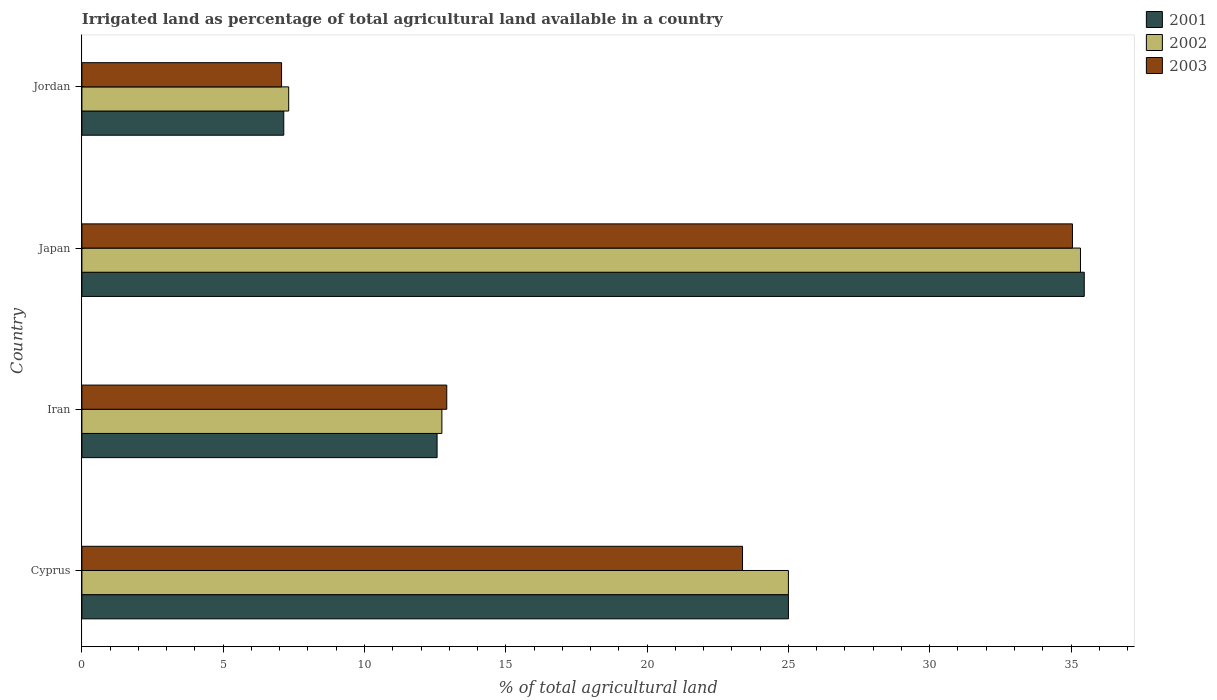How many groups of bars are there?
Your response must be concise. 4. Are the number of bars on each tick of the Y-axis equal?
Offer a terse response. Yes. How many bars are there on the 1st tick from the top?
Your answer should be very brief. 3. What is the label of the 1st group of bars from the top?
Give a very brief answer. Jordan. In how many cases, is the number of bars for a given country not equal to the number of legend labels?
Offer a terse response. 0. What is the percentage of irrigated land in 2003 in Iran?
Your answer should be very brief. 12.91. Across all countries, what is the maximum percentage of irrigated land in 2002?
Make the answer very short. 35.33. Across all countries, what is the minimum percentage of irrigated land in 2001?
Offer a terse response. 7.14. In which country was the percentage of irrigated land in 2001 minimum?
Ensure brevity in your answer.  Jordan. What is the total percentage of irrigated land in 2002 in the graph?
Offer a terse response. 80.39. What is the difference between the percentage of irrigated land in 2003 in Japan and that in Jordan?
Make the answer very short. 27.99. What is the difference between the percentage of irrigated land in 2003 in Japan and the percentage of irrigated land in 2002 in Iran?
Your response must be concise. 22.31. What is the average percentage of irrigated land in 2002 per country?
Give a very brief answer. 20.1. What is the difference between the percentage of irrigated land in 2002 and percentage of irrigated land in 2003 in Cyprus?
Make the answer very short. 1.62. What is the ratio of the percentage of irrigated land in 2003 in Iran to that in Jordan?
Your answer should be compact. 1.83. What is the difference between the highest and the second highest percentage of irrigated land in 2002?
Offer a very short reply. 10.33. What is the difference between the highest and the lowest percentage of irrigated land in 2001?
Offer a terse response. 28.33. In how many countries, is the percentage of irrigated land in 2003 greater than the average percentage of irrigated land in 2003 taken over all countries?
Your answer should be compact. 2. Is the sum of the percentage of irrigated land in 2001 in Cyprus and Japan greater than the maximum percentage of irrigated land in 2003 across all countries?
Provide a short and direct response. Yes. Is it the case that in every country, the sum of the percentage of irrigated land in 2002 and percentage of irrigated land in 2001 is greater than the percentage of irrigated land in 2003?
Your answer should be very brief. Yes. How many bars are there?
Your answer should be compact. 12. Are all the bars in the graph horizontal?
Provide a short and direct response. Yes. What is the difference between two consecutive major ticks on the X-axis?
Make the answer very short. 5. Are the values on the major ticks of X-axis written in scientific E-notation?
Keep it short and to the point. No. Does the graph contain any zero values?
Provide a succinct answer. No. Does the graph contain grids?
Give a very brief answer. No. How are the legend labels stacked?
Ensure brevity in your answer.  Vertical. What is the title of the graph?
Make the answer very short. Irrigated land as percentage of total agricultural land available in a country. What is the label or title of the X-axis?
Make the answer very short. % of total agricultural land. What is the label or title of the Y-axis?
Give a very brief answer. Country. What is the % of total agricultural land in 2002 in Cyprus?
Provide a succinct answer. 25. What is the % of total agricultural land in 2003 in Cyprus?
Provide a succinct answer. 23.38. What is the % of total agricultural land in 2001 in Iran?
Your answer should be compact. 12.57. What is the % of total agricultural land in 2002 in Iran?
Offer a terse response. 12.74. What is the % of total agricultural land in 2003 in Iran?
Offer a very short reply. 12.91. What is the % of total agricultural land in 2001 in Japan?
Make the answer very short. 35.47. What is the % of total agricultural land in 2002 in Japan?
Offer a very short reply. 35.33. What is the % of total agricultural land of 2003 in Japan?
Your answer should be very brief. 35.05. What is the % of total agricultural land of 2001 in Jordan?
Give a very brief answer. 7.14. What is the % of total agricultural land of 2002 in Jordan?
Ensure brevity in your answer.  7.32. What is the % of total agricultural land in 2003 in Jordan?
Your response must be concise. 7.06. Across all countries, what is the maximum % of total agricultural land of 2001?
Provide a succinct answer. 35.47. Across all countries, what is the maximum % of total agricultural land of 2002?
Provide a short and direct response. 35.33. Across all countries, what is the maximum % of total agricultural land of 2003?
Your answer should be compact. 35.05. Across all countries, what is the minimum % of total agricultural land of 2001?
Your answer should be compact. 7.14. Across all countries, what is the minimum % of total agricultural land of 2002?
Your response must be concise. 7.32. Across all countries, what is the minimum % of total agricultural land in 2003?
Offer a terse response. 7.06. What is the total % of total agricultural land of 2001 in the graph?
Your answer should be compact. 80.18. What is the total % of total agricultural land in 2002 in the graph?
Provide a short and direct response. 80.39. What is the total % of total agricultural land in 2003 in the graph?
Make the answer very short. 78.4. What is the difference between the % of total agricultural land of 2001 in Cyprus and that in Iran?
Provide a succinct answer. 12.43. What is the difference between the % of total agricultural land in 2002 in Cyprus and that in Iran?
Provide a succinct answer. 12.26. What is the difference between the % of total agricultural land of 2003 in Cyprus and that in Iran?
Your answer should be compact. 10.47. What is the difference between the % of total agricultural land of 2001 in Cyprus and that in Japan?
Give a very brief answer. -10.47. What is the difference between the % of total agricultural land of 2002 in Cyprus and that in Japan?
Ensure brevity in your answer.  -10.33. What is the difference between the % of total agricultural land in 2003 in Cyprus and that in Japan?
Your answer should be compact. -11.67. What is the difference between the % of total agricultural land in 2001 in Cyprus and that in Jordan?
Keep it short and to the point. 17.86. What is the difference between the % of total agricultural land in 2002 in Cyprus and that in Jordan?
Ensure brevity in your answer.  17.68. What is the difference between the % of total agricultural land of 2003 in Cyprus and that in Jordan?
Keep it short and to the point. 16.31. What is the difference between the % of total agricultural land of 2001 in Iran and that in Japan?
Your response must be concise. -22.9. What is the difference between the % of total agricultural land of 2002 in Iran and that in Japan?
Make the answer very short. -22.6. What is the difference between the % of total agricultural land in 2003 in Iran and that in Japan?
Give a very brief answer. -22.14. What is the difference between the % of total agricultural land in 2001 in Iran and that in Jordan?
Provide a short and direct response. 5.42. What is the difference between the % of total agricultural land of 2002 in Iran and that in Jordan?
Make the answer very short. 5.42. What is the difference between the % of total agricultural land in 2003 in Iran and that in Jordan?
Ensure brevity in your answer.  5.85. What is the difference between the % of total agricultural land in 2001 in Japan and that in Jordan?
Keep it short and to the point. 28.33. What is the difference between the % of total agricultural land of 2002 in Japan and that in Jordan?
Make the answer very short. 28.02. What is the difference between the % of total agricultural land in 2003 in Japan and that in Jordan?
Make the answer very short. 27.99. What is the difference between the % of total agricultural land in 2001 in Cyprus and the % of total agricultural land in 2002 in Iran?
Offer a terse response. 12.26. What is the difference between the % of total agricultural land in 2001 in Cyprus and the % of total agricultural land in 2003 in Iran?
Provide a succinct answer. 12.09. What is the difference between the % of total agricultural land of 2002 in Cyprus and the % of total agricultural land of 2003 in Iran?
Ensure brevity in your answer.  12.09. What is the difference between the % of total agricultural land of 2001 in Cyprus and the % of total agricultural land of 2002 in Japan?
Offer a terse response. -10.33. What is the difference between the % of total agricultural land in 2001 in Cyprus and the % of total agricultural land in 2003 in Japan?
Your answer should be very brief. -10.05. What is the difference between the % of total agricultural land of 2002 in Cyprus and the % of total agricultural land of 2003 in Japan?
Your response must be concise. -10.05. What is the difference between the % of total agricultural land of 2001 in Cyprus and the % of total agricultural land of 2002 in Jordan?
Your answer should be compact. 17.68. What is the difference between the % of total agricultural land in 2001 in Cyprus and the % of total agricultural land in 2003 in Jordan?
Provide a succinct answer. 17.94. What is the difference between the % of total agricultural land in 2002 in Cyprus and the % of total agricultural land in 2003 in Jordan?
Keep it short and to the point. 17.94. What is the difference between the % of total agricultural land in 2001 in Iran and the % of total agricultural land in 2002 in Japan?
Your answer should be very brief. -22.77. What is the difference between the % of total agricultural land in 2001 in Iran and the % of total agricultural land in 2003 in Japan?
Give a very brief answer. -22.48. What is the difference between the % of total agricultural land in 2002 in Iran and the % of total agricultural land in 2003 in Japan?
Offer a very short reply. -22.31. What is the difference between the % of total agricultural land in 2001 in Iran and the % of total agricultural land in 2002 in Jordan?
Give a very brief answer. 5.25. What is the difference between the % of total agricultural land in 2001 in Iran and the % of total agricultural land in 2003 in Jordan?
Your answer should be very brief. 5.5. What is the difference between the % of total agricultural land in 2002 in Iran and the % of total agricultural land in 2003 in Jordan?
Your response must be concise. 5.67. What is the difference between the % of total agricultural land in 2001 in Japan and the % of total agricultural land in 2002 in Jordan?
Give a very brief answer. 28.15. What is the difference between the % of total agricultural land of 2001 in Japan and the % of total agricultural land of 2003 in Jordan?
Your answer should be compact. 28.4. What is the difference between the % of total agricultural land in 2002 in Japan and the % of total agricultural land in 2003 in Jordan?
Offer a very short reply. 28.27. What is the average % of total agricultural land of 2001 per country?
Provide a succinct answer. 20.04. What is the average % of total agricultural land in 2002 per country?
Offer a terse response. 20.1. What is the average % of total agricultural land in 2003 per country?
Offer a terse response. 19.6. What is the difference between the % of total agricultural land in 2001 and % of total agricultural land in 2003 in Cyprus?
Keep it short and to the point. 1.62. What is the difference between the % of total agricultural land of 2002 and % of total agricultural land of 2003 in Cyprus?
Keep it short and to the point. 1.62. What is the difference between the % of total agricultural land in 2001 and % of total agricultural land in 2002 in Iran?
Your response must be concise. -0.17. What is the difference between the % of total agricultural land of 2001 and % of total agricultural land of 2003 in Iran?
Keep it short and to the point. -0.34. What is the difference between the % of total agricultural land of 2002 and % of total agricultural land of 2003 in Iran?
Provide a short and direct response. -0.17. What is the difference between the % of total agricultural land of 2001 and % of total agricultural land of 2002 in Japan?
Offer a terse response. 0.13. What is the difference between the % of total agricultural land in 2001 and % of total agricultural land in 2003 in Japan?
Make the answer very short. 0.42. What is the difference between the % of total agricultural land of 2002 and % of total agricultural land of 2003 in Japan?
Offer a terse response. 0.28. What is the difference between the % of total agricultural land in 2001 and % of total agricultural land in 2002 in Jordan?
Keep it short and to the point. -0.17. What is the difference between the % of total agricultural land in 2001 and % of total agricultural land in 2003 in Jordan?
Make the answer very short. 0.08. What is the difference between the % of total agricultural land in 2002 and % of total agricultural land in 2003 in Jordan?
Provide a short and direct response. 0.25. What is the ratio of the % of total agricultural land in 2001 in Cyprus to that in Iran?
Provide a succinct answer. 1.99. What is the ratio of the % of total agricultural land in 2002 in Cyprus to that in Iran?
Give a very brief answer. 1.96. What is the ratio of the % of total agricultural land in 2003 in Cyprus to that in Iran?
Make the answer very short. 1.81. What is the ratio of the % of total agricultural land of 2001 in Cyprus to that in Japan?
Offer a very short reply. 0.7. What is the ratio of the % of total agricultural land in 2002 in Cyprus to that in Japan?
Your answer should be compact. 0.71. What is the ratio of the % of total agricultural land in 2003 in Cyprus to that in Japan?
Offer a terse response. 0.67. What is the ratio of the % of total agricultural land of 2001 in Cyprus to that in Jordan?
Ensure brevity in your answer.  3.5. What is the ratio of the % of total agricultural land of 2002 in Cyprus to that in Jordan?
Ensure brevity in your answer.  3.42. What is the ratio of the % of total agricultural land of 2003 in Cyprus to that in Jordan?
Ensure brevity in your answer.  3.31. What is the ratio of the % of total agricultural land of 2001 in Iran to that in Japan?
Ensure brevity in your answer.  0.35. What is the ratio of the % of total agricultural land in 2002 in Iran to that in Japan?
Offer a very short reply. 0.36. What is the ratio of the % of total agricultural land of 2003 in Iran to that in Japan?
Ensure brevity in your answer.  0.37. What is the ratio of the % of total agricultural land in 2001 in Iran to that in Jordan?
Give a very brief answer. 1.76. What is the ratio of the % of total agricultural land of 2002 in Iran to that in Jordan?
Keep it short and to the point. 1.74. What is the ratio of the % of total agricultural land of 2003 in Iran to that in Jordan?
Ensure brevity in your answer.  1.83. What is the ratio of the % of total agricultural land of 2001 in Japan to that in Jordan?
Provide a short and direct response. 4.97. What is the ratio of the % of total agricultural land of 2002 in Japan to that in Jordan?
Make the answer very short. 4.83. What is the ratio of the % of total agricultural land of 2003 in Japan to that in Jordan?
Offer a terse response. 4.96. What is the difference between the highest and the second highest % of total agricultural land of 2001?
Your response must be concise. 10.47. What is the difference between the highest and the second highest % of total agricultural land of 2002?
Provide a short and direct response. 10.33. What is the difference between the highest and the second highest % of total agricultural land in 2003?
Make the answer very short. 11.67. What is the difference between the highest and the lowest % of total agricultural land in 2001?
Your response must be concise. 28.33. What is the difference between the highest and the lowest % of total agricultural land of 2002?
Your answer should be very brief. 28.02. What is the difference between the highest and the lowest % of total agricultural land in 2003?
Your answer should be compact. 27.99. 